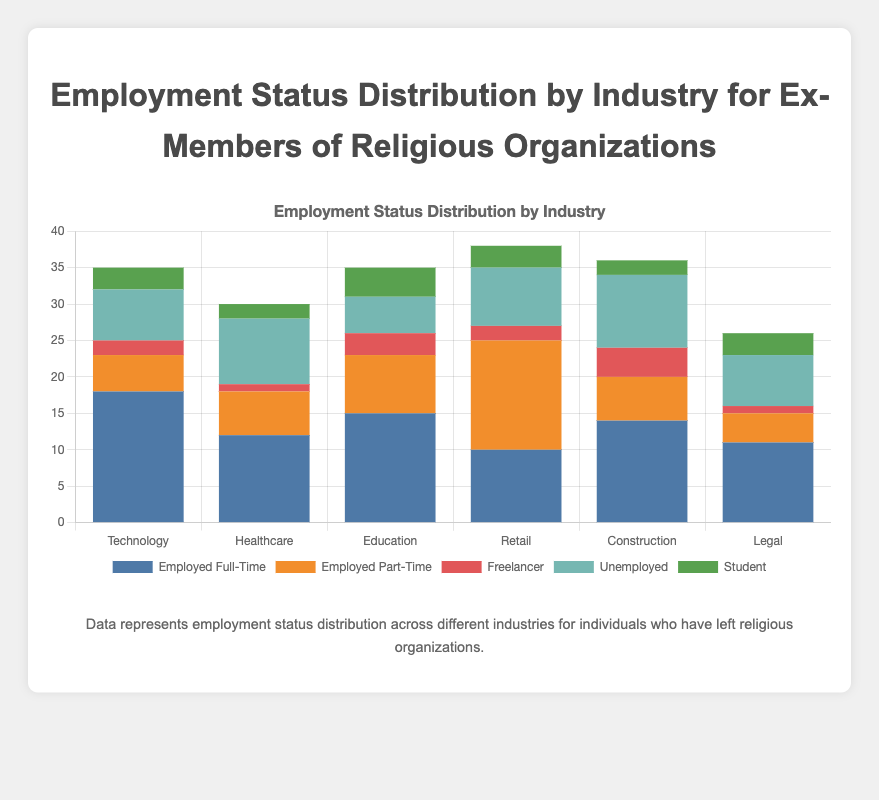Which industry has the highest number of ex-religious members employed full-time? The highest bar in the "Employed Full-Time" segment needs to be identified. In the chart data, Technology has 18 employed full-time members, the highest among all industries.
Answer: Technology What is the total number of unemployed ex-religious members in all industries combined? Sum the "Unemployed" counts for all industries: 7 (Technology) + 9 (Healthcare) + 5 (Education) + 8 (Retail) + 10 (Construction) + 7 (Legal) = 46.
Answer: 46 Which industry has more part-time employed than full-time employed? Compare the height of the "Employed Part-Time" and "Employed Full-Time" bars for each industry. The Retail industry has 10 full-time and 15 part-time employed, showing more part-time employment.
Answer: Retail How many total students are represented across all industries? Sum the "Student" counts for all industries: 3 (Technology) + 2 (Healthcare) + 4 (Education) + 3 (Retail) + 2 (Construction) + 3 (Legal) = 17.
Answer: 17 In which industry are freelancers most represented? Identify the highest bar in the "Freelancer" segment. In the chart data, Construction has 4 freelancers, the highest number among all industries.
Answer: Construction Which employment status has the fewest representatives in the Healthcare industry? Identify the smallest bar in the Healthcare segment. "Freelancer" has 1 member, the fewest among all employment statuses in Healthcare.
Answer: Freelancer What is the average number of part-time employed members across all industries? Find the "Employed Part-Time" numbers for each industry and then calculate the average: (5 + 6 + 8 + 15 + 6 + 4) / 6 = 44 / 6 ≈ 7.33.
Answer: 7.33 Are there more full-time employed ex-members or unemployed ex-members in the Education industry? Compare the numbers for "Employed Full-Time" and "Unemployed" in Education. Full-time employed are 15, and unemployed are 5. There are more full-time employed.
Answer: Full-time employed Which industry has the fewest students? Identify the lowest bar in the "Student" segment. Both Healthcare and Construction have the fewest students, with 2 each.
Answer: Healthcare and Construction 